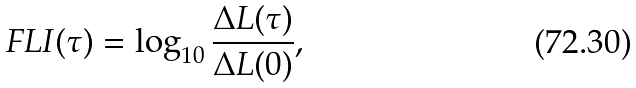Convert formula to latex. <formula><loc_0><loc_0><loc_500><loc_500>F L I ( \tau ) = \log _ { 1 0 } \frac { \Delta L ( \tau ) } { \Delta L ( 0 ) } ,</formula> 